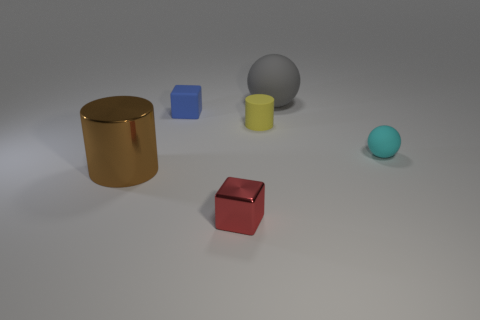Add 2 metallic things. How many objects exist? 8 Subtract all balls. How many objects are left? 4 Subtract all cyan things. Subtract all small cyan matte balls. How many objects are left? 4 Add 6 red cubes. How many red cubes are left? 7 Add 1 large brown metallic balls. How many large brown metallic balls exist? 1 Subtract 0 blue balls. How many objects are left? 6 